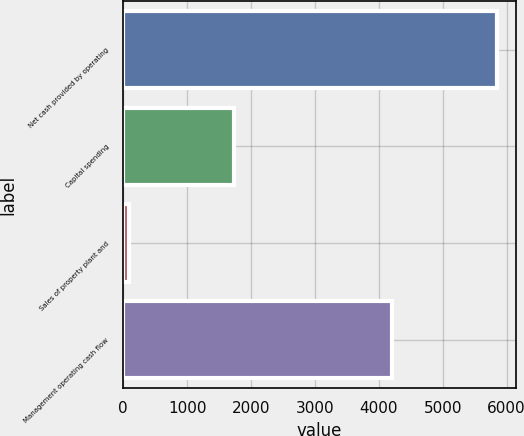Convert chart to OTSL. <chart><loc_0><loc_0><loc_500><loc_500><bar_chart><fcel>Net cash provided by operating<fcel>Capital spending<fcel>Sales of property plant and<fcel>Management operating cash flow<nl><fcel>5852<fcel>1736<fcel>88<fcel>4204<nl></chart> 